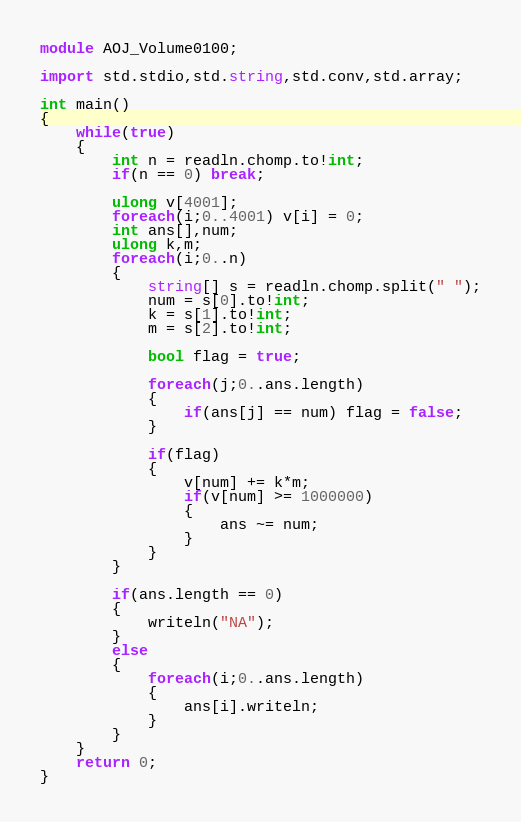<code> <loc_0><loc_0><loc_500><loc_500><_D_>module AOJ_Volume0100;

import std.stdio,std.string,std.conv,std.array;

int main()
{
	while(true)
	{
		int n = readln.chomp.to!int;
		if(n == 0) break;

		ulong v[4001];
		foreach(i;0..4001) v[i] = 0;
		int ans[],num;
		ulong k,m;
		foreach(i;0..n)
		{
			string[] s = readln.chomp.split(" ");
			num = s[0].to!int;
			k = s[1].to!int;
			m = s[2].to!int;

			bool flag = true;

			foreach(j;0..ans.length)
			{
				if(ans[j] == num) flag = false;
			}

			if(flag)
			{
				v[num] += k*m;
				if(v[num] >= 1000000)
				{
					ans ~= num;
				}
			}
		}

		if(ans.length == 0)
		{
			writeln("NA");
		}
		else
		{
			foreach(i;0..ans.length)
			{
				ans[i].writeln;
			}
		}
	}
	return 0;
}</code> 